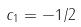<formula> <loc_0><loc_0><loc_500><loc_500>c _ { 1 } = - 1 / 2</formula> 